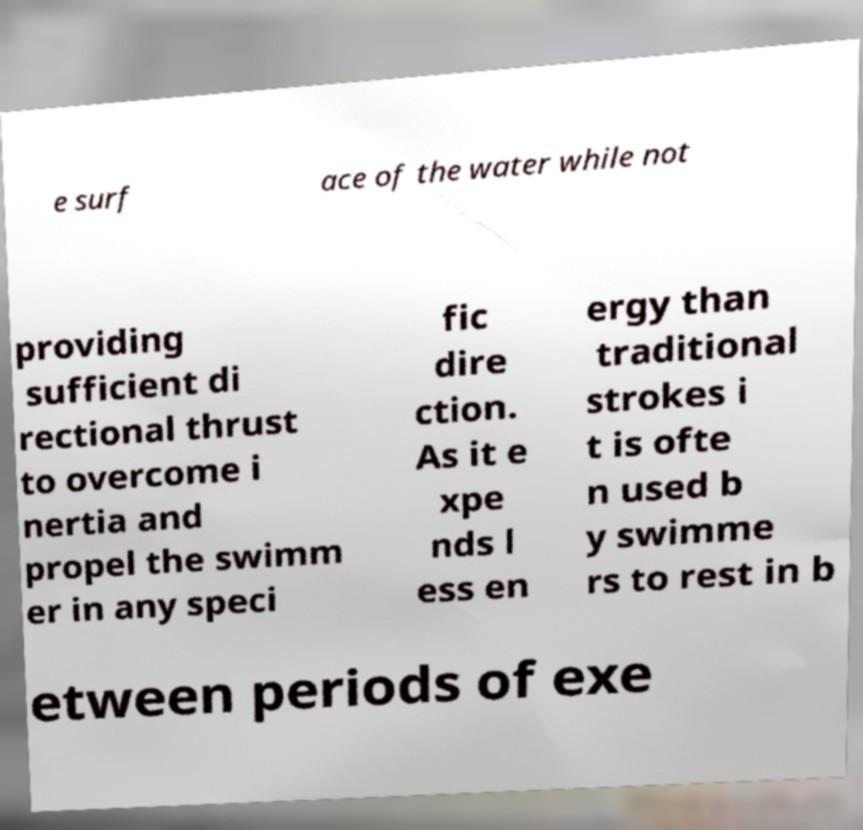I need the written content from this picture converted into text. Can you do that? e surf ace of the water while not providing sufficient di rectional thrust to overcome i nertia and propel the swimm er in any speci fic dire ction. As it e xpe nds l ess en ergy than traditional strokes i t is ofte n used b y swimme rs to rest in b etween periods of exe 